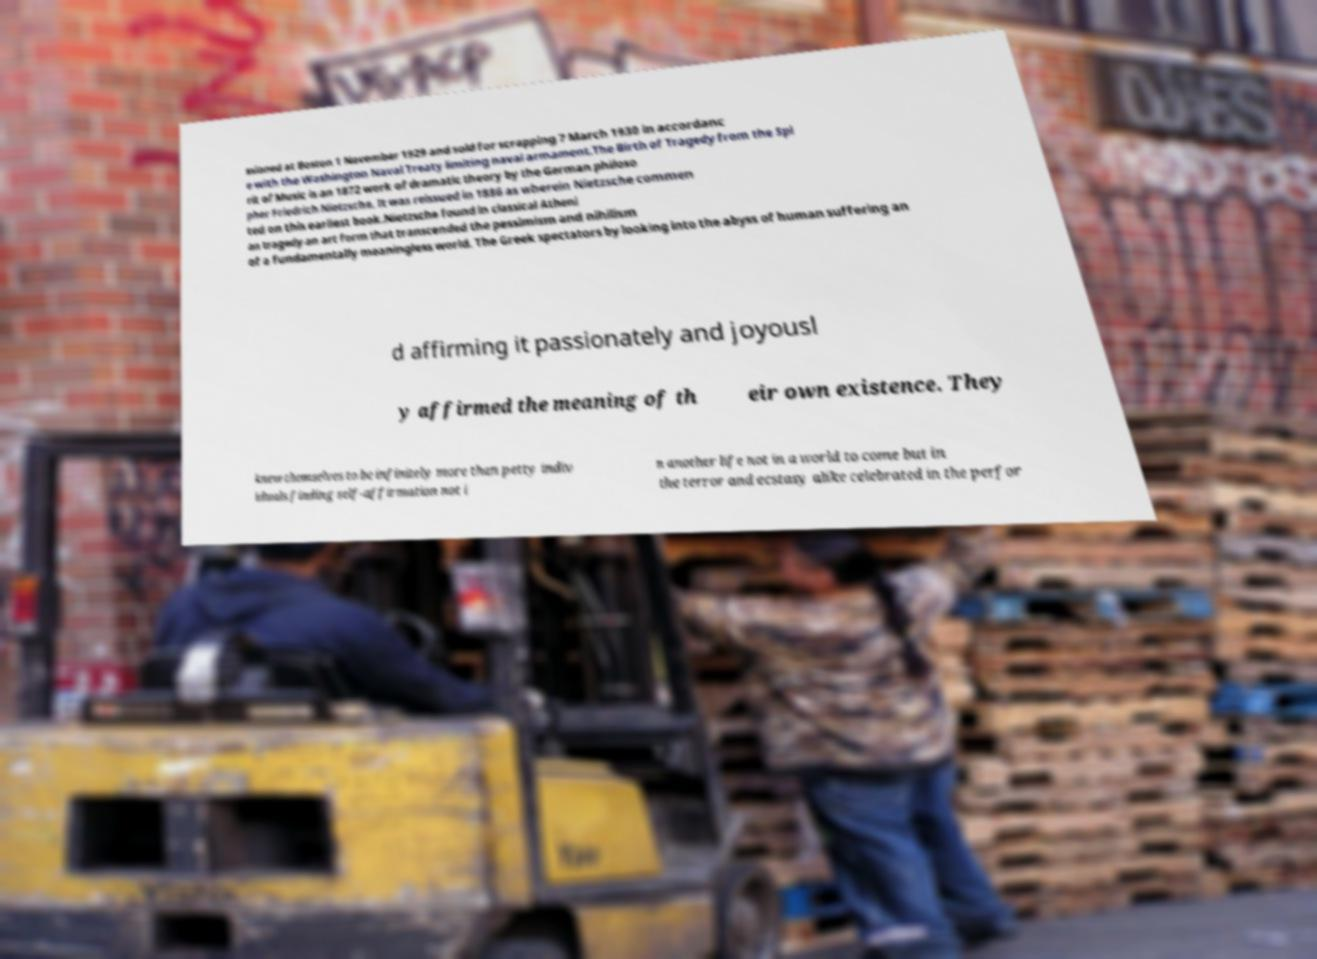Could you extract and type out the text from this image? ssioned at Boston 1 November 1929 and sold for scrapping 7 March 1930 in accordanc e with the Washington Naval Treaty limiting naval armament.The Birth of Tragedy from the Spi rit of Music is an 1872 work of dramatic theory by the German philoso pher Friedrich Nietzsche. It was reissued in 1886 as wherein Nietzsche commen ted on this earliest book.Nietzsche found in classical Atheni an tragedy an art form that transcended the pessimism and nihilism of a fundamentally meaningless world. The Greek spectators by looking into the abyss of human suffering an d affirming it passionately and joyousl y affirmed the meaning of th eir own existence. They knew themselves to be infinitely more than petty indiv iduals finding self-affirmation not i n another life not in a world to come but in the terror and ecstasy alike celebrated in the perfor 